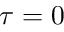Convert formula to latex. <formula><loc_0><loc_0><loc_500><loc_500>\tau = 0</formula> 